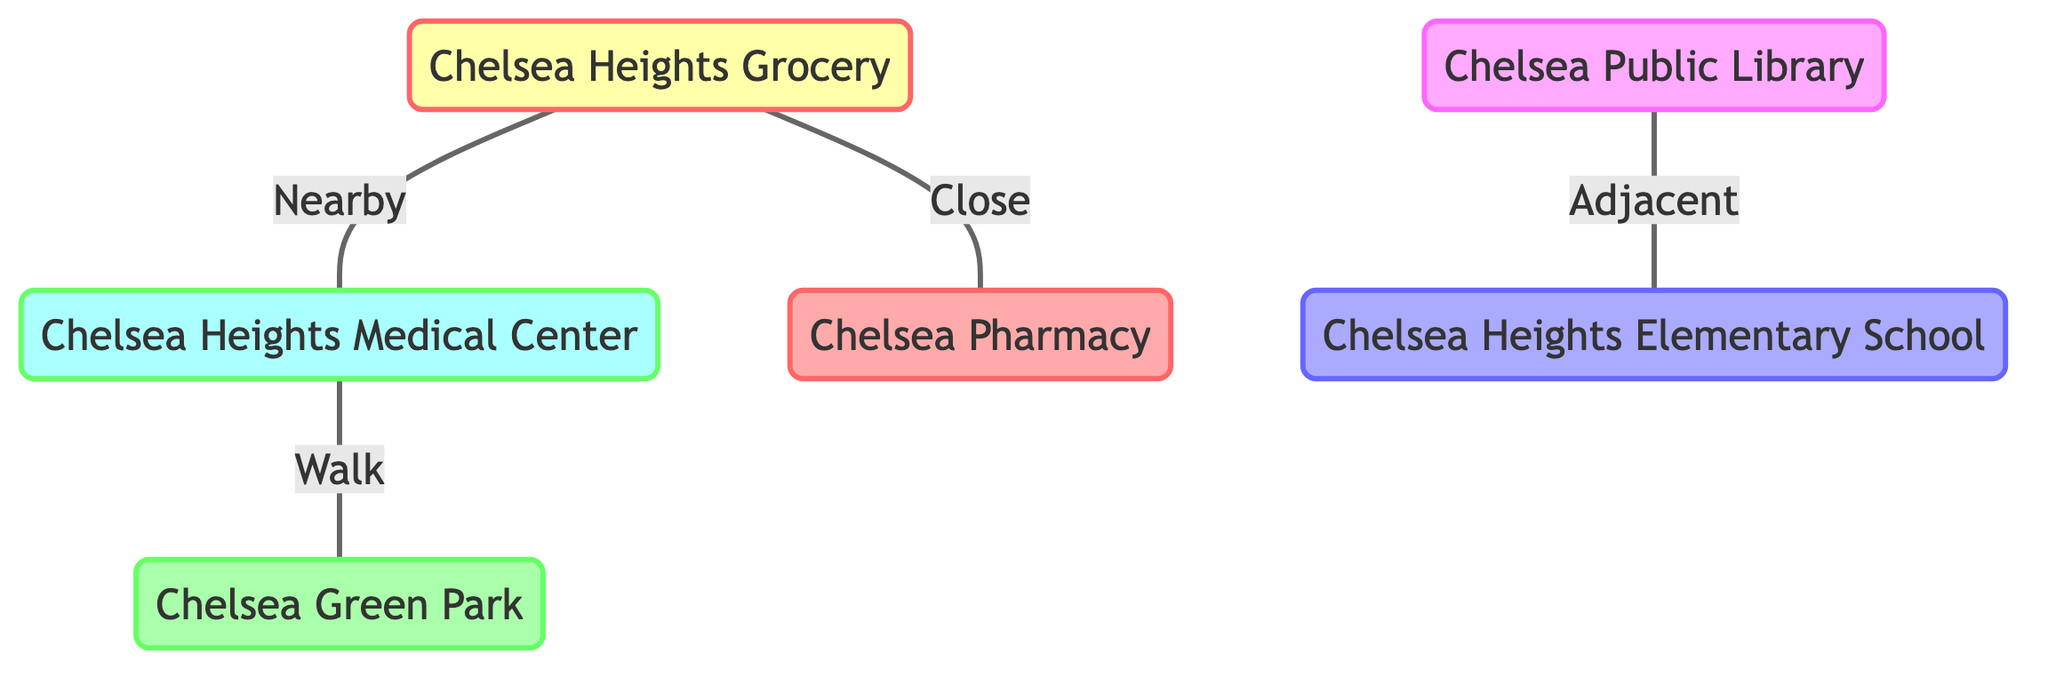What is located adjacent to the Chelsea Public Library? The diagram indicates that the Chelsea Public Library is adjacent to Chelsea Heights Elementary School. This is shown through a direct relationship line connecting the two nodes.
Answer: Chelsea Heights Elementary School How many essential locations are represented in the diagram? The diagram lists six essential locations: Chelsea Heights Grocery, Chelsea Heights Medical Center, Chelsea Green Park, Chelsea Public Library, Chelsea Heights Elementary School, and Chelsea Pharmacy. Counting these nodes gives us the total number of essential locations represented.
Answer: 6 Which place is nearby the Chelsea Heights Grocery? According to the diagram, the Chelsea Heights Grocery is connected to the Chelsea Heights Medical Center by a line labeled "Nearby". This indicates that these two places have a proximity relationship.
Answer: Chelsea Heights Medical Center What connects the hospital and the park? The relationship between the Chelsea Heights Medical Center and Chelsea Green Park is described as "Walk". This indicates that one can walk from the hospital to the park, showing a direct connection between these two places.
Answer: Walk Which location is located close to the grocery store? The diagram shows that the Chelsea Pharmacy is connected to the Chelsea Heights Grocery with a line labeled "Close". This indicates the proximity of these two places.
Answer: Chelsea Pharmacy How are the school and library related? The Chelsea Public Library is described as "Adjacent" to Chelsea Heights Elementary School, indicating a direct connection where both are near each other.
Answer: Adjacent Which essential location is not a store or a pharmacy? The Chelsea Green Park, represented in the diagram, is neither a store nor a pharmacy. This is evident from the classification of nodes present in the diagram.
Answer: Chelsea Green Park What type of structure is this diagram? The diagram is a Textbook Diagram that illustrates relationships among multiple essential locations in Chelsea Heights, clearly mapping out their proximity and associations.
Answer: Textbook Diagram 